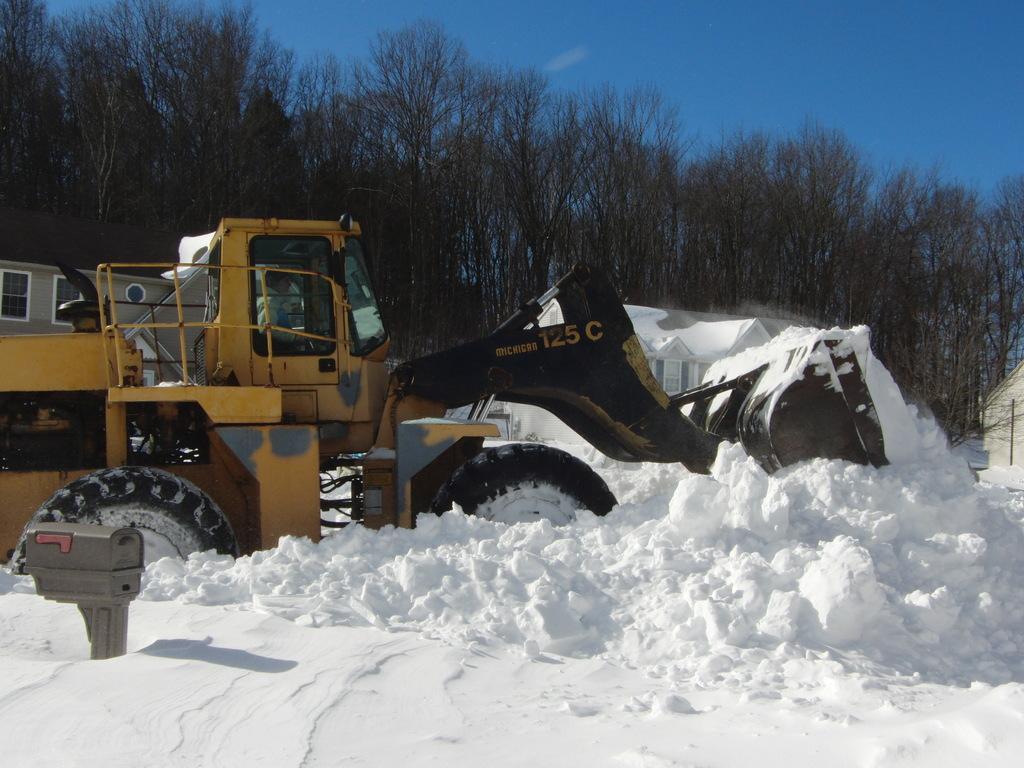In one or two sentences, can you explain what this image depicts? In this picture we can observe yellow color bulldozer on the snow. We can observe some snow on the land. In the background there is a house. We can observe some trees and a sky. 